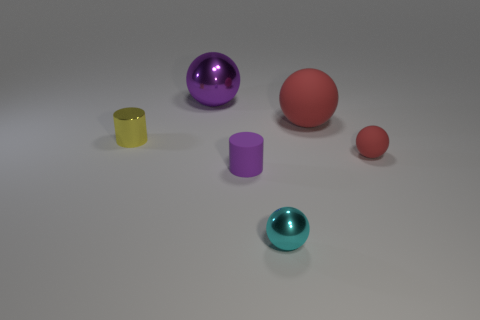Could you describe the arrangement of the objects with respect to their colors? Certainly. In the image, the objects are scattered across a flat surface, presenting a mix of colors. From left to right, there is a small translucent yellow cylinder; a large purple shiny sphere; a matte, slightly purple cylinder; a large red sphere with a rubber texture; and a smaller red sphere. Lastly, a teal-colored shiny sphere sits in the foreground, closest to the viewer. 